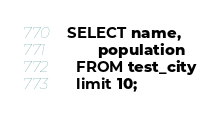<code> <loc_0><loc_0><loc_500><loc_500><_SQL_>SELECT name,
       population
  FROM test_city
  limit 10;
</code> 